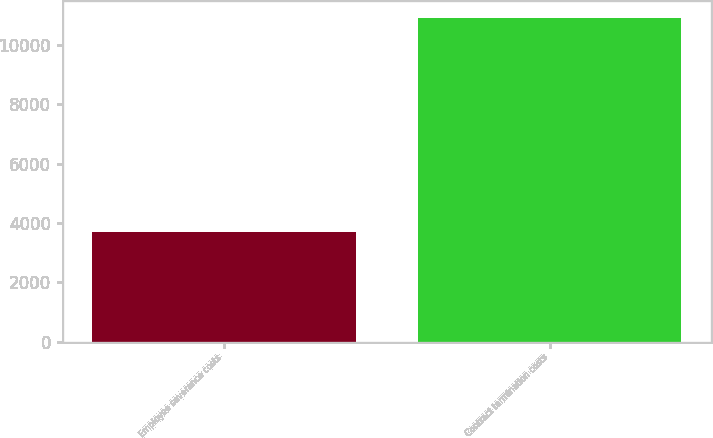Convert chart to OTSL. <chart><loc_0><loc_0><loc_500><loc_500><bar_chart><fcel>Employee severance costs<fcel>Contract termination costs<nl><fcel>3688<fcel>10919<nl></chart> 